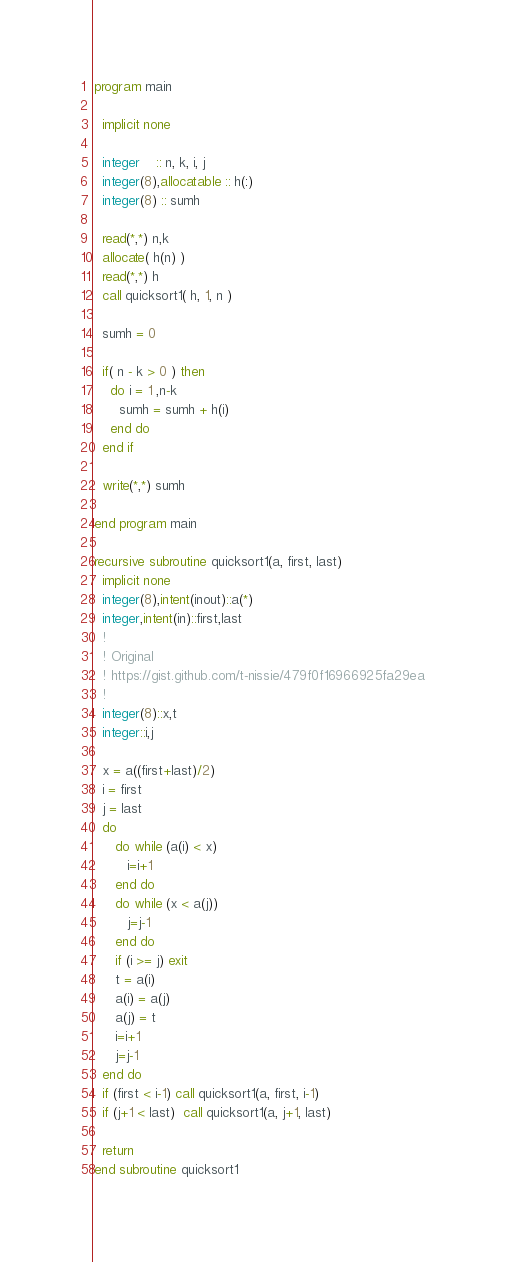Convert code to text. <code><loc_0><loc_0><loc_500><loc_500><_FORTRAN_>program main

  implicit none

  integer    :: n, k, i, j
  integer(8),allocatable :: h(:)
  integer(8) :: sumh
  
  read(*,*) n,k
  allocate( h(n) )
  read(*,*) h
  call quicksort1( h, 1, n ) 

  sumh = 0

  if( n - k > 0 ) then
    do i = 1 ,n-k
      sumh = sumh + h(i)
    end do
  end if

  write(*,*) sumh

end program main

recursive subroutine quicksort1(a, first, last)
  implicit none
  integer(8),intent(inout)::a(*)
  integer,intent(in)::first,last
  !
  ! Original
  ! https://gist.github.com/t-nissie/479f0f16966925fa29ea
  !
  integer(8)::x,t
  integer::i,j

  x = a((first+last)/2)
  i = first
  j = last
  do
     do while (a(i) < x)
        i=i+1
     end do
     do while (x < a(j))
        j=j-1
     end do
     if (i >= j) exit
     t = a(i)
     a(i) = a(j)
     a(j) = t
     i=i+1
     j=j-1
  end do
  if (first < i-1) call quicksort1(a, first, i-1)
  if (j+1 < last)  call quicksort1(a, j+1, last)

  return
end subroutine quicksort1
</code> 